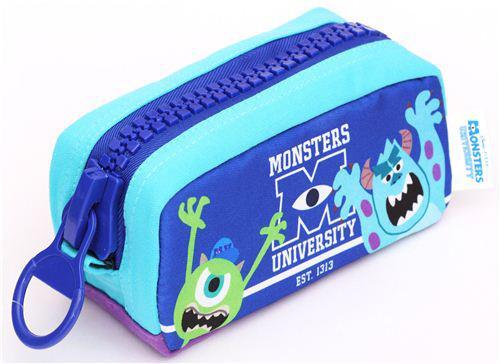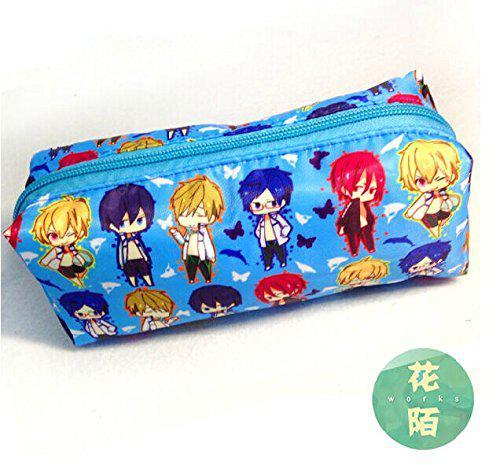The first image is the image on the left, the second image is the image on the right. Examine the images to the left and right. Is the description "Each image shows a single closed case, and all cases feature blue in their color scheme." accurate? Answer yes or no. Yes. The first image is the image on the left, the second image is the image on the right. Evaluate the accuracy of this statement regarding the images: "There are more pencil cases in the image on the right.". Is it true? Answer yes or no. No. The first image is the image on the left, the second image is the image on the right. Given the left and right images, does the statement "Only two pencil cases are visible in the pair of images." hold true? Answer yes or no. Yes. The first image is the image on the left, the second image is the image on the right. Evaluate the accuracy of this statement regarding the images: "There are only two pencil cases, and both are closed.". Is it true? Answer yes or no. Yes. 